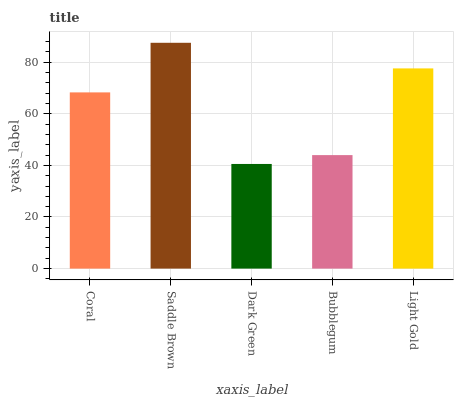Is Dark Green the minimum?
Answer yes or no. Yes. Is Saddle Brown the maximum?
Answer yes or no. Yes. Is Saddle Brown the minimum?
Answer yes or no. No. Is Dark Green the maximum?
Answer yes or no. No. Is Saddle Brown greater than Dark Green?
Answer yes or no. Yes. Is Dark Green less than Saddle Brown?
Answer yes or no. Yes. Is Dark Green greater than Saddle Brown?
Answer yes or no. No. Is Saddle Brown less than Dark Green?
Answer yes or no. No. Is Coral the high median?
Answer yes or no. Yes. Is Coral the low median?
Answer yes or no. Yes. Is Light Gold the high median?
Answer yes or no. No. Is Dark Green the low median?
Answer yes or no. No. 